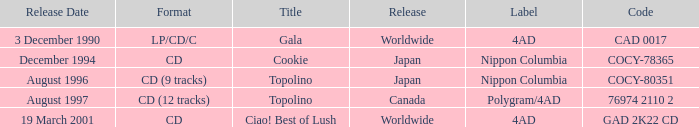When was Gala released? Worldwide. 